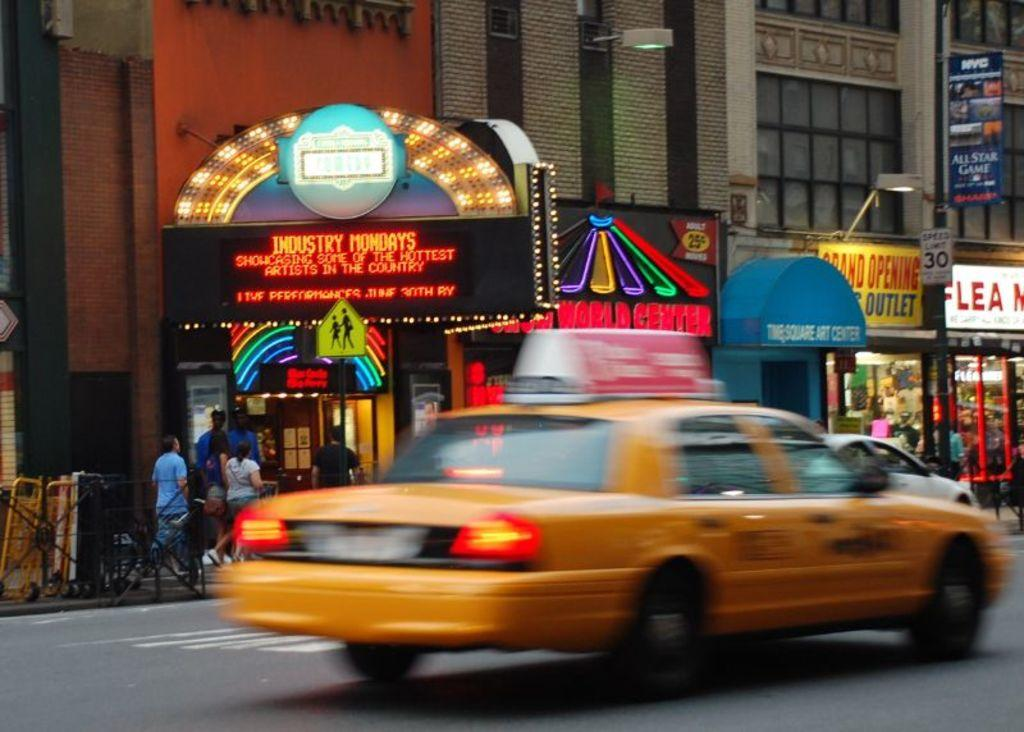<image>
Summarize the visual content of the image. A taxi driving by a digital marquee that says Industry Mondays. 